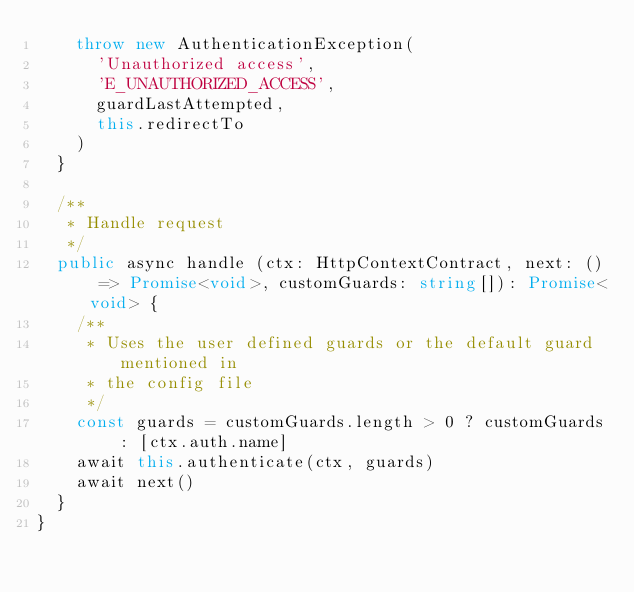Convert code to text. <code><loc_0><loc_0><loc_500><loc_500><_TypeScript_>    throw new AuthenticationException(
      'Unauthorized access',
      'E_UNAUTHORIZED_ACCESS',
      guardLastAttempted,
      this.redirectTo
    )
  }

  /**
   * Handle request
   */
  public async handle (ctx: HttpContextContract, next: () => Promise<void>, customGuards: string[]): Promise<void> {
    /**
     * Uses the user defined guards or the default guard mentioned in
     * the config file
     */
    const guards = customGuards.length > 0 ? customGuards : [ctx.auth.name]
    await this.authenticate(ctx, guards)
    await next()
  }
}
</code> 